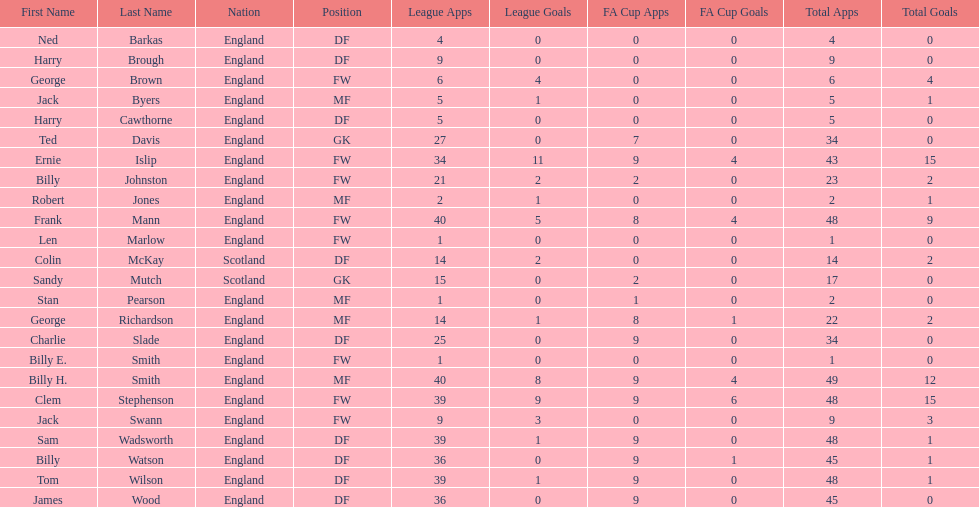How many players are fws? 8. 